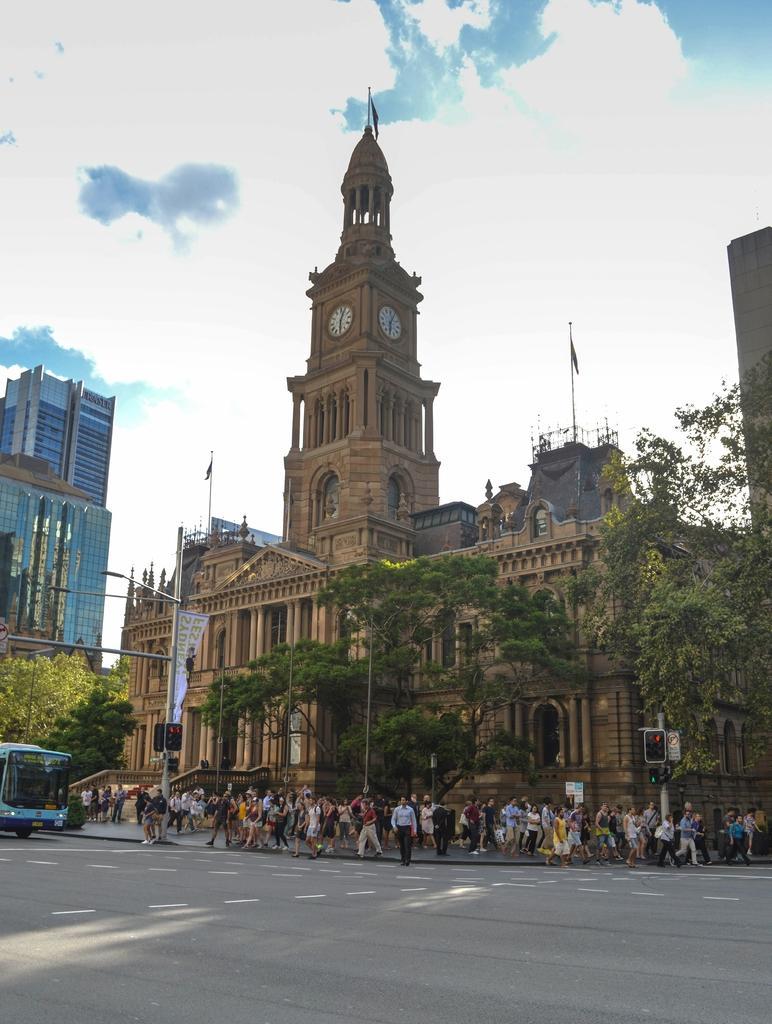How would you summarize this image in a sentence or two? In this image I can see the road, a bus on the road, the sidewalk, number of persons standing on the sidewalk, few traffic signals, few poles, few trees and few buildings. In the background I can see the sky. 